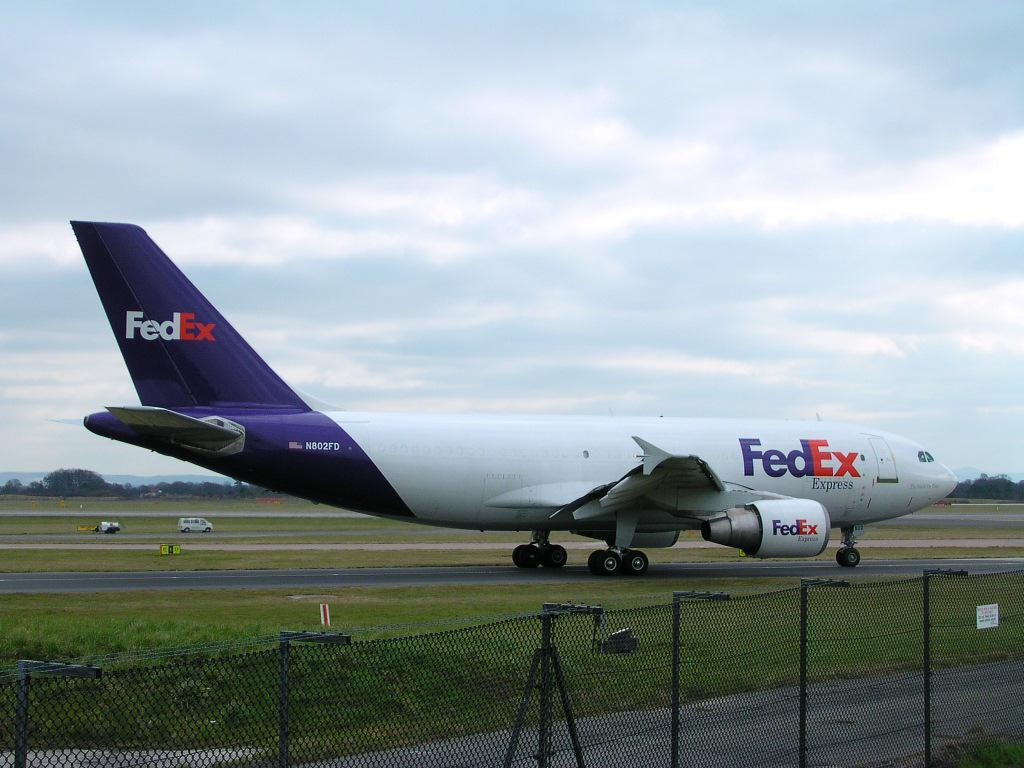<image>
Create a compact narrative representing the image presented. a large Fedex plane is landed on the tarmack 